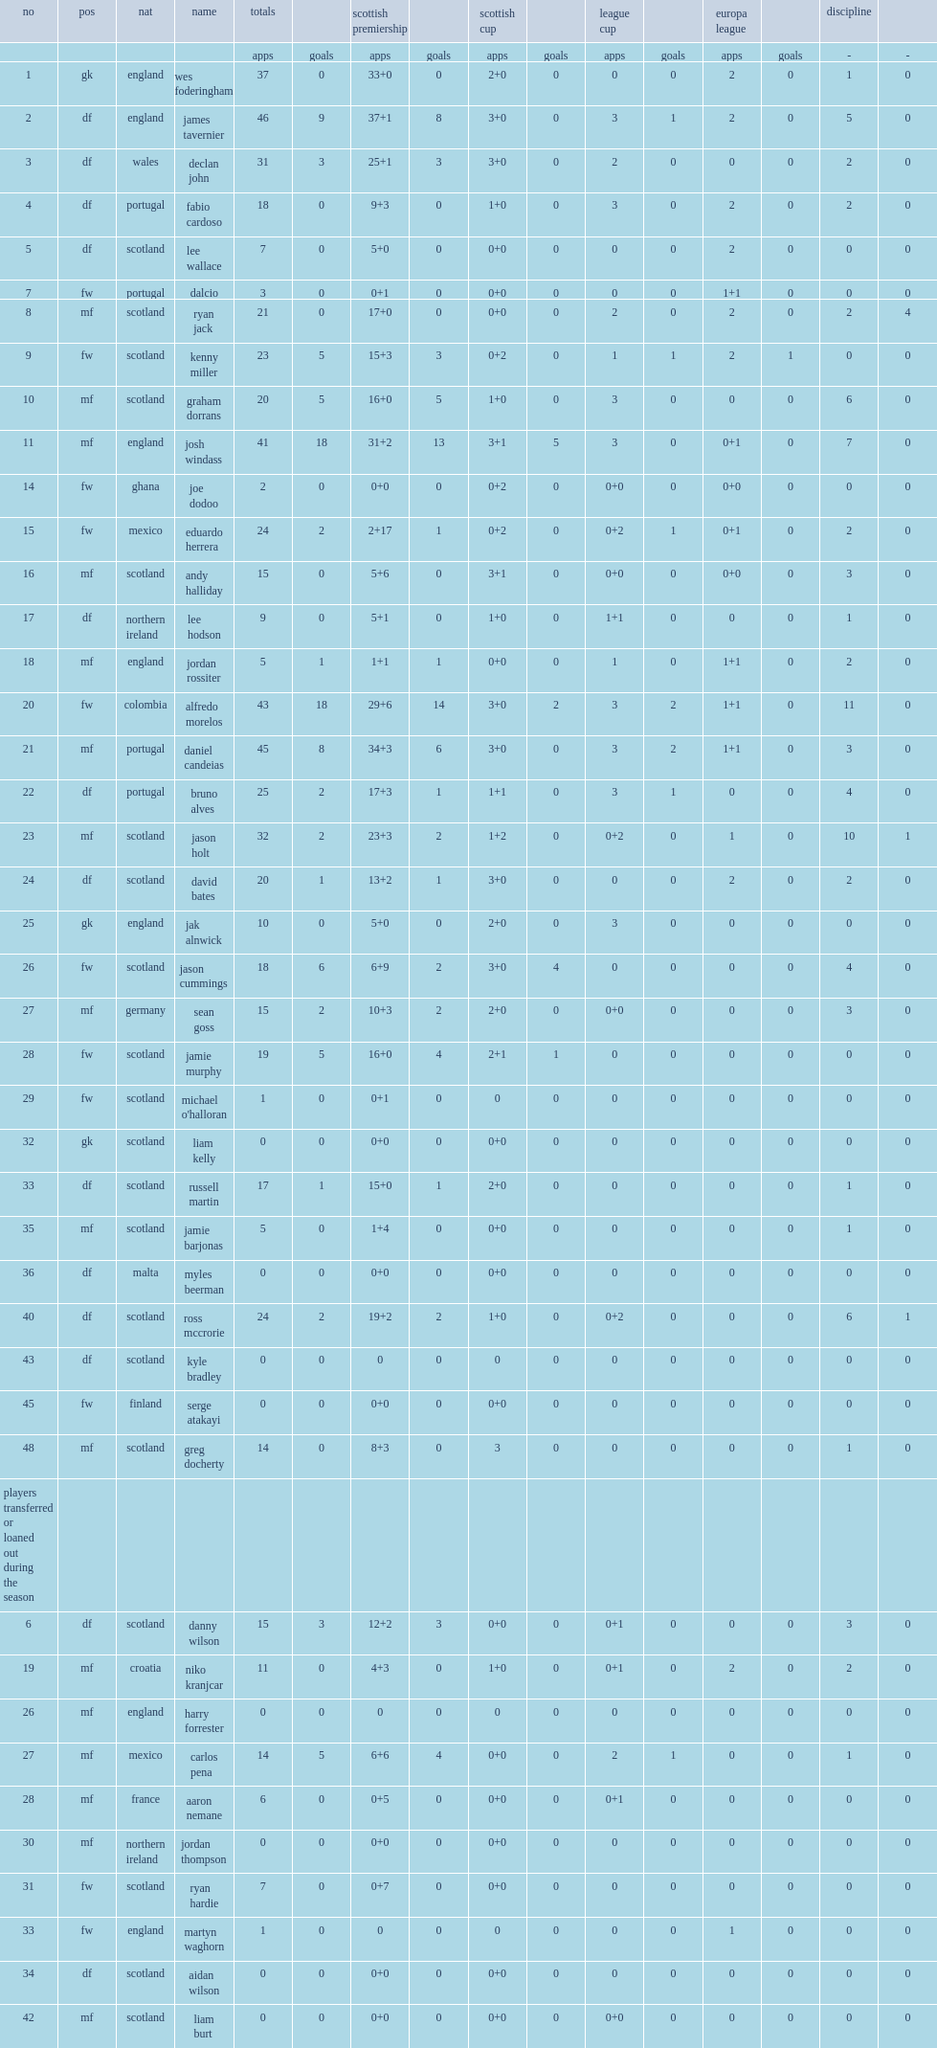What the matches did appearances and goal totals include? Scottish premiership scottish cup league cup europa league. 